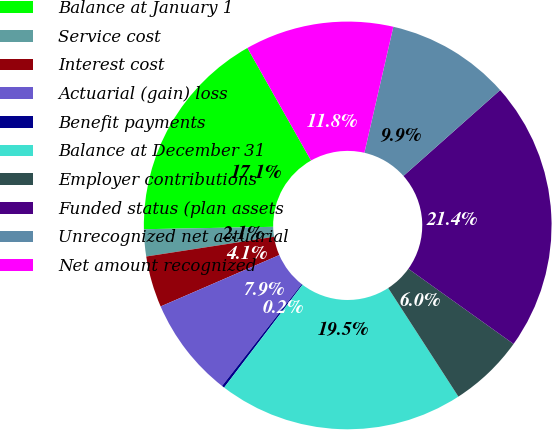Convert chart. <chart><loc_0><loc_0><loc_500><loc_500><pie_chart><fcel>Balance at January 1<fcel>Service cost<fcel>Interest cost<fcel>Actuarial (gain) loss<fcel>Benefit payments<fcel>Balance at December 31<fcel>Employer contributions<fcel>Funded status (plan assets<fcel>Unrecognized net actuarial<fcel>Net amount recognized<nl><fcel>17.11%<fcel>2.14%<fcel>4.07%<fcel>7.92%<fcel>0.21%<fcel>19.5%<fcel>5.99%<fcel>21.43%<fcel>9.85%<fcel>11.78%<nl></chart> 